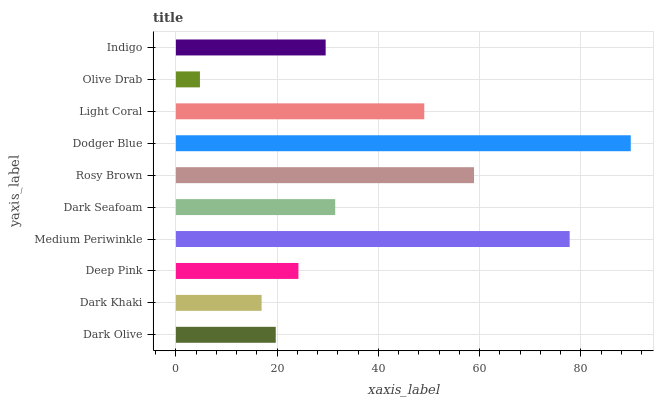Is Olive Drab the minimum?
Answer yes or no. Yes. Is Dodger Blue the maximum?
Answer yes or no. Yes. Is Dark Khaki the minimum?
Answer yes or no. No. Is Dark Khaki the maximum?
Answer yes or no. No. Is Dark Olive greater than Dark Khaki?
Answer yes or no. Yes. Is Dark Khaki less than Dark Olive?
Answer yes or no. Yes. Is Dark Khaki greater than Dark Olive?
Answer yes or no. No. Is Dark Olive less than Dark Khaki?
Answer yes or no. No. Is Dark Seafoam the high median?
Answer yes or no. Yes. Is Indigo the low median?
Answer yes or no. Yes. Is Indigo the high median?
Answer yes or no. No. Is Light Coral the low median?
Answer yes or no. No. 